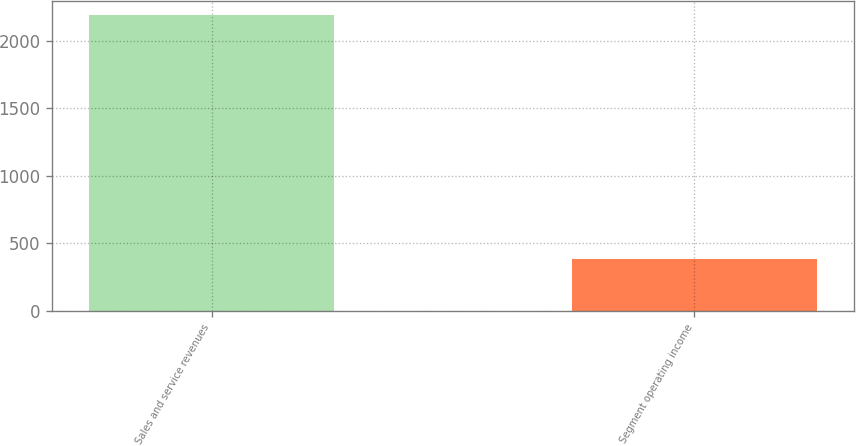Convert chart. <chart><loc_0><loc_0><loc_500><loc_500><bar_chart><fcel>Sales and service revenues<fcel>Segment operating income<nl><fcel>2188<fcel>379<nl></chart> 